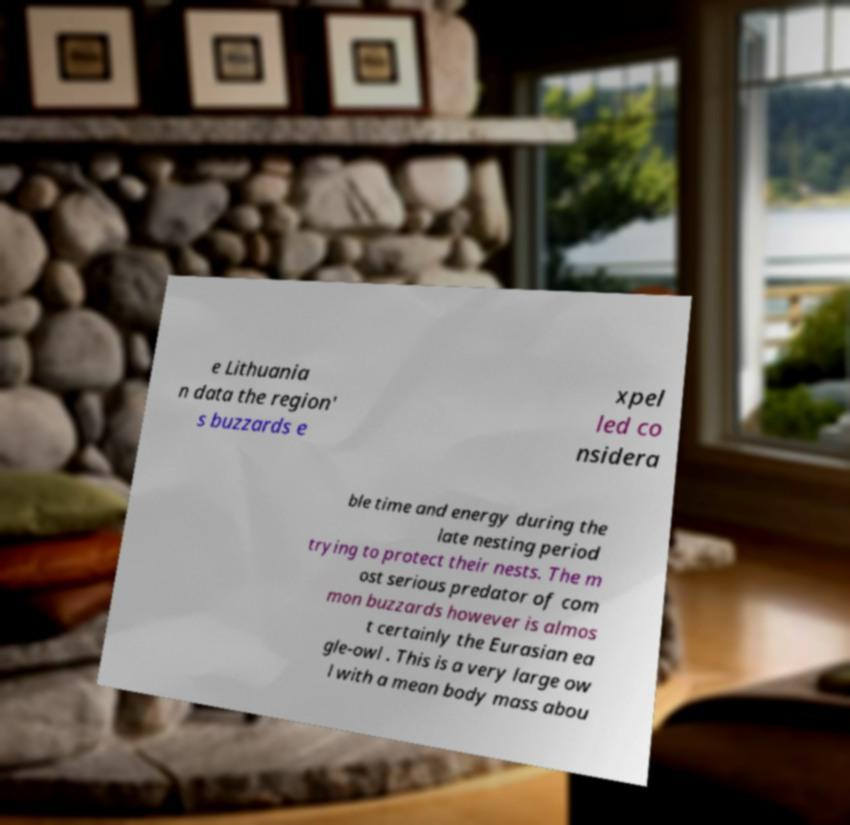Please read and relay the text visible in this image. What does it say? e Lithuania n data the region' s buzzards e xpel led co nsidera ble time and energy during the late nesting period trying to protect their nests. The m ost serious predator of com mon buzzards however is almos t certainly the Eurasian ea gle-owl . This is a very large ow l with a mean body mass abou 